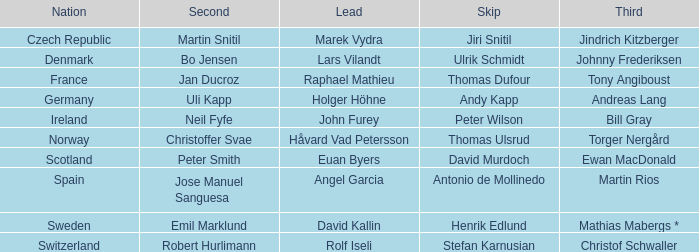Which Skip has a Third of tony angiboust? Thomas Dufour. 